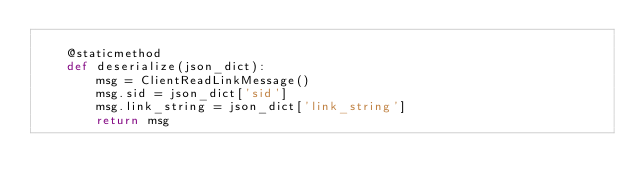Convert code to text. <code><loc_0><loc_0><loc_500><loc_500><_Python_>
    @staticmethod
    def deserialize(json_dict):
        msg = ClientReadLinkMessage()
        msg.sid = json_dict['sid']
        msg.link_string = json_dict['link_string']
        return msg

</code> 